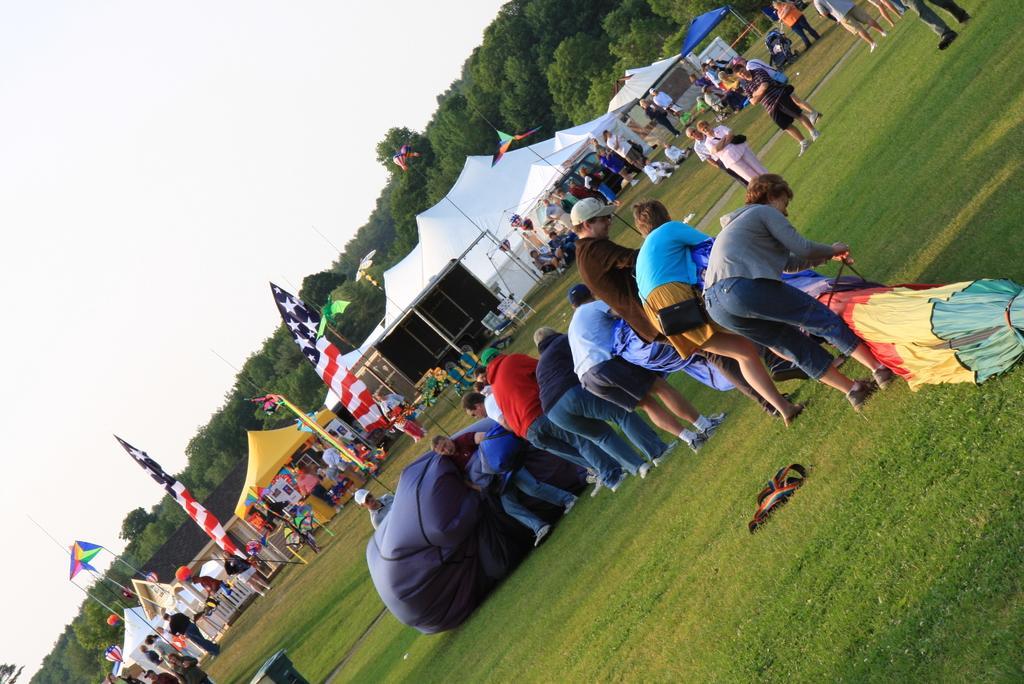How would you summarize this image in a sentence or two? In this image, I can see groups of people standing and few people are holding a hot air balloon. I can see the flags hanging to the poles. These are the canopy tents. I can see the trees. This is the grass. I think this is the kind of a belt, which is lying on the grass. 